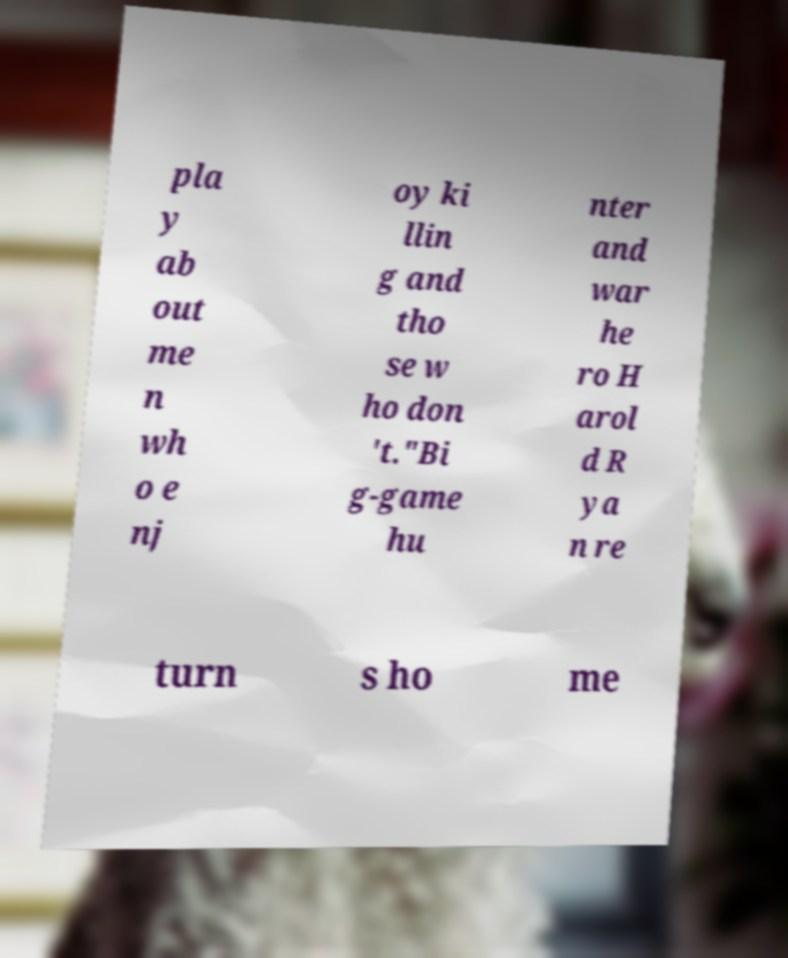For documentation purposes, I need the text within this image transcribed. Could you provide that? pla y ab out me n wh o e nj oy ki llin g and tho se w ho don 't."Bi g-game hu nter and war he ro H arol d R ya n re turn s ho me 